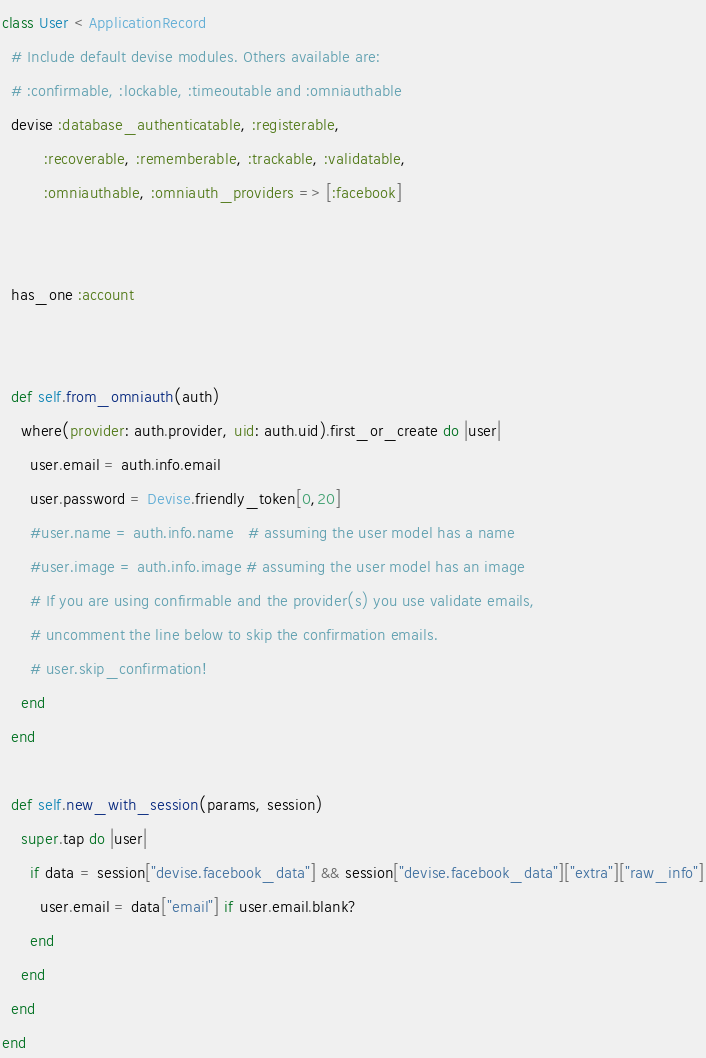<code> <loc_0><loc_0><loc_500><loc_500><_Ruby_>class User < ApplicationRecord
  # Include default devise modules. Others available are:
  # :confirmable, :lockable, :timeoutable and :omniauthable
  devise :database_authenticatable, :registerable,
         :recoverable, :rememberable, :trackable, :validatable,
         :omniauthable, :omniauth_providers => [:facebook]


  has_one :account


  def self.from_omniauth(auth)
    where(provider: auth.provider, uid: auth.uid).first_or_create do |user|
      user.email = auth.info.email
      user.password = Devise.friendly_token[0,20]
      #user.name = auth.info.name   # assuming the user model has a name
      #user.image = auth.info.image # assuming the user model has an image
      # If you are using confirmable and the provider(s) you use validate emails, 
      # uncomment the line below to skip the confirmation emails.
      # user.skip_confirmation!
    end
  end

  def self.new_with_session(params, session)
    super.tap do |user|
      if data = session["devise.facebook_data"] && session["devise.facebook_data"]["extra"]["raw_info"]
        user.email = data["email"] if user.email.blank?
      end
    end
  end
end
</code> 